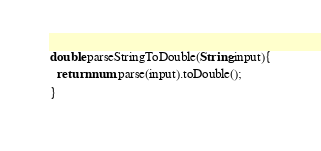Convert code to text. <code><loc_0><loc_0><loc_500><loc_500><_Dart_>double parseStringToDouble(String input){
  return num.parse(input).toDouble();
}</code> 